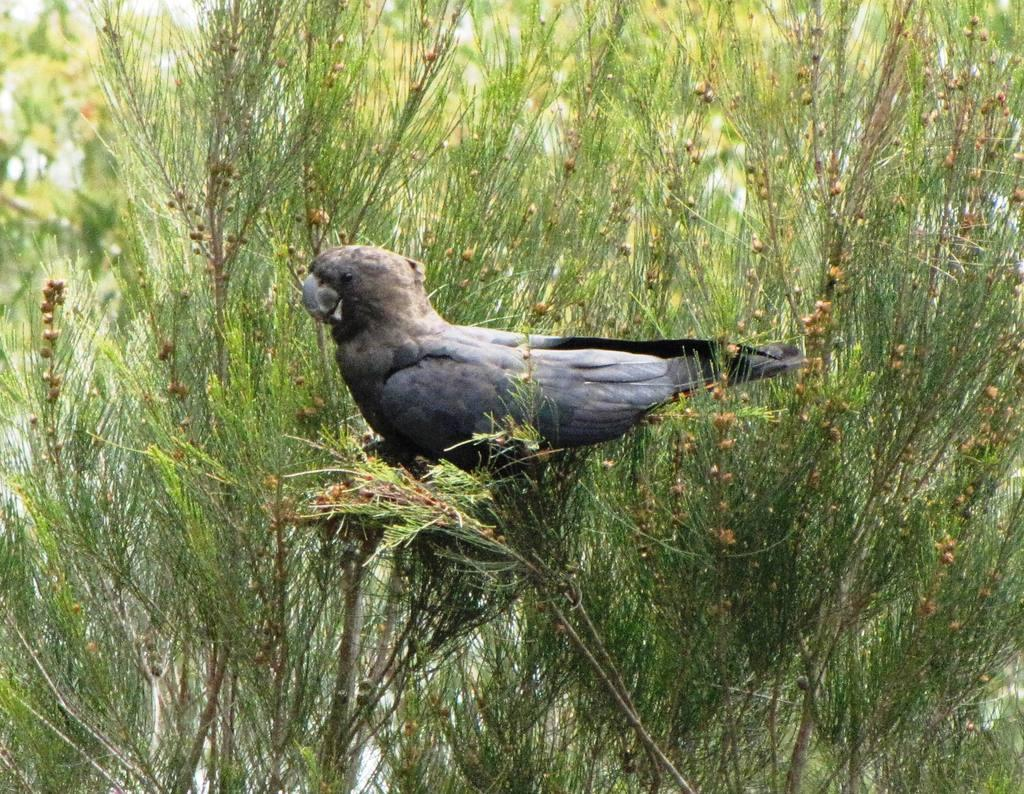What type of animal is in the picture? There is a bird in the picture. Can you describe the bird's appearance? The bird is gray and black in color. What is the bird standing on? The bird is standing on grass plants. Can you see the donkey kicking the bird in the picture? There is no donkey or kicking action present in the image; it features a bird standing on grass plants. 